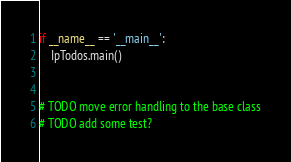<code> <loc_0><loc_0><loc_500><loc_500><_Python_>
if __name__ == '__main__':
    IpTodos.main()


# TODO move error handling to the base class
# TODO add some test?
</code> 